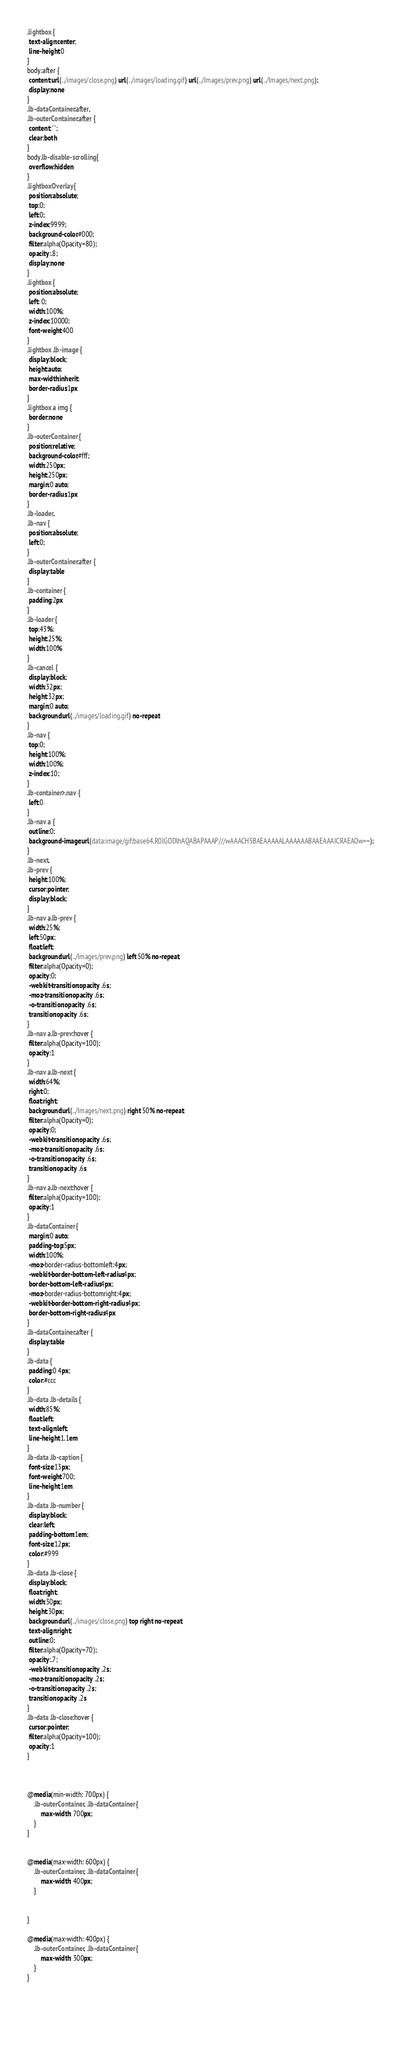<code> <loc_0><loc_0><loc_500><loc_500><_CSS_>.lightbox {
 text-align:center;
 line-height:0
}
body:after {
 content:url(../images/close.png) url(../images/loading.gif) url(../Images/prev.png) url(../Images/next.png);
 display:none
}
.lb-dataContainer:after,
.lb-outerContainer:after {
 content:"";
 clear:both
}
body.lb-disable-scrolling {
 overflow:hidden
}
.lightboxOverlay {
 position:absolute;
 top:0;
 left:0;
 z-index:9999;
 background-color:#000;
 filter:alpha(Opacity=80);
 opacity:.8;
 display:none
}
.lightbox {
 position:absolute;
 left: 0;
 width:100%;
 z-index:10000;
 font-weight:400
}
.lightbox .lb-image {
 display:block;
 height:auto;
 max-width:inherit;
 border-radius:1px
}
.lightbox a img {
 border:none
}
.lb-outerContainer {
 position:relative;
 background-color:#fff;
 width:250px;
 height:250px;
 margin:0 auto;
 border-radius:1px
}
.lb-loader,
.lb-nav {
 position:absolute;
 left:0;
}
.lb-outerContainer:after {
 display:table
}
.lb-container {
 padding:2px
}
.lb-loader {
 top:43%;
 height:25%;
 width:100%
}
.lb-cancel {
 display:block;
 width:32px;
 height:32px;
 margin:0 auto;
 background:url(../images/loading.gif) no-repeat
}
.lb-nav {
 top:0;
 height:100%;
 width:100%;
 z-index:10;
}
.lb-container>.nav {
 left:0
}
.lb-nav a {
 outline:0;
 background-image:url(data:image/gif;base64,R0lGODlhAQABAPAAAP///wAAACH5BAEAAAAALAAAAAABAAEAAAICRAEAOw==);
}
.lb-next,
.lb-prev {
 height:100%;
 cursor:pointer;
 display:block;
}
.lb-nav a.lb-prev {
 width:25%;
 left:50px;
 float:left;
 background:url(../Images/prev.png) left 50% no-repeat;
 filter:alpha(Opacity=0);
 opacity:0;
 -webkit-transition:opacity .6s;
 -moz-transition:opacity .6s;
 -o-transition:opacity .6s;
 transition:opacity .6s;
}
.lb-nav a.lb-prev:hover {
 filter:alpha(Opacity=100);
 opacity:1
}
.lb-nav a.lb-next {
 width:64%;
 right:0;
 float:right;
 background:url(../Images/next.png) right 50% no-repeat;
 filter:alpha(Opacity=0);
 opacity:0;
 -webkit-transition:opacity .6s;
 -moz-transition:opacity .6s;
 -o-transition:opacity .6s;
 transition:opacity .6s
}
.lb-nav a.lb-next:hover {
 filter:alpha(Opacity=100);
 opacity:1
}
.lb-dataContainer {
 margin:0 auto;
 padding-top:5px;
 width:100%;
 -moz-border-radius-bottomleft:4px;
 -webkit-border-bottom-left-radius:4px;
 border-bottom-left-radius:4px;
 -moz-border-radius-bottomright:4px;
 -webkit-border-bottom-right-radius:4px;
 border-bottom-right-radius:4px
}
.lb-dataContainer:after {
 display:table
}
.lb-data {
 padding:0 4px;
 color:#ccc
}
.lb-data .lb-details {
 width:85%;
 float:left;
 text-align:left;
 line-height:1.1em
}
.lb-data .lb-caption {
 font-size:13px;
 font-weight:700;
 line-height:1em
}
.lb-data .lb-number {
 display:block;
 clear:left;
 padding-bottom:1em;
 font-size:12px;
 color:#999
}
.lb-data .lb-close {
 display:block;
 float:right;
 width:30px;
 height:30px;
 background:url(../images/close.png) top right no-repeat;
 text-align:right;
 outline:0;
 filter:alpha(Opacity=70);
 opacity:.7;
 -webkit-transition:opacity .2s;
 -moz-transition:opacity .2s;
 -o-transition:opacity .2s;
 transition:opacity .2s
}
.lb-data .lb-close:hover {
 cursor:pointer;
 filter:alpha(Opacity=100);
 opacity:1
}



@media(min-width: 700px) {
    .lb-outerContainer, .lb-dataContainer {
        max-width: 700px;
    }
}


@media(max-width: 600px) {
    .lb-outerContainer, .lb-dataContainer {
        max-width: 400px;
    }

    
}

@media(max-width: 400px) {
    .lb-outerContainer, .lb-dataContainer {
        max-width: 300px;
    }
}



    


</code> 